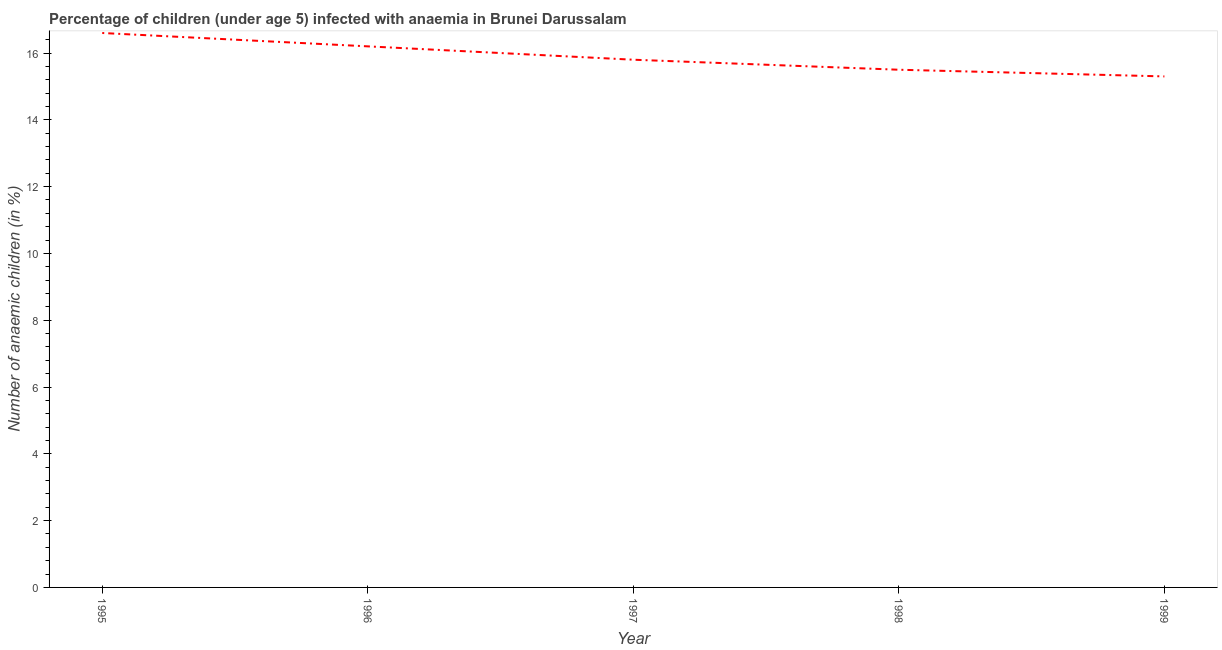What is the number of anaemic children in 1998?
Make the answer very short. 15.5. Across all years, what is the maximum number of anaemic children?
Provide a succinct answer. 16.6. Across all years, what is the minimum number of anaemic children?
Your response must be concise. 15.3. In which year was the number of anaemic children maximum?
Your response must be concise. 1995. What is the sum of the number of anaemic children?
Provide a succinct answer. 79.4. What is the difference between the number of anaemic children in 1996 and 1998?
Provide a succinct answer. 0.7. What is the average number of anaemic children per year?
Offer a very short reply. 15.88. In how many years, is the number of anaemic children greater than 11.6 %?
Your answer should be compact. 5. Do a majority of the years between 1995 and 1996 (inclusive) have number of anaemic children greater than 7.2 %?
Provide a short and direct response. Yes. What is the ratio of the number of anaemic children in 1997 to that in 1998?
Keep it short and to the point. 1.02. What is the difference between the highest and the second highest number of anaemic children?
Make the answer very short. 0.4. What is the difference between the highest and the lowest number of anaemic children?
Give a very brief answer. 1.3. In how many years, is the number of anaemic children greater than the average number of anaemic children taken over all years?
Keep it short and to the point. 2. Does the number of anaemic children monotonically increase over the years?
Your answer should be very brief. No. Are the values on the major ticks of Y-axis written in scientific E-notation?
Your answer should be compact. No. Does the graph contain any zero values?
Keep it short and to the point. No. What is the title of the graph?
Give a very brief answer. Percentage of children (under age 5) infected with anaemia in Brunei Darussalam. What is the label or title of the Y-axis?
Give a very brief answer. Number of anaemic children (in %). What is the Number of anaemic children (in %) of 1998?
Offer a terse response. 15.5. What is the difference between the Number of anaemic children (in %) in 1995 and 1996?
Provide a succinct answer. 0.4. What is the difference between the Number of anaemic children (in %) in 1995 and 1998?
Your response must be concise. 1.1. What is the difference between the Number of anaemic children (in %) in 1995 and 1999?
Provide a short and direct response. 1.3. What is the difference between the Number of anaemic children (in %) in 1996 and 1999?
Ensure brevity in your answer.  0.9. What is the difference between the Number of anaemic children (in %) in 1997 and 1999?
Offer a very short reply. 0.5. What is the difference between the Number of anaemic children (in %) in 1998 and 1999?
Your response must be concise. 0.2. What is the ratio of the Number of anaemic children (in %) in 1995 to that in 1996?
Offer a very short reply. 1.02. What is the ratio of the Number of anaemic children (in %) in 1995 to that in 1997?
Make the answer very short. 1.05. What is the ratio of the Number of anaemic children (in %) in 1995 to that in 1998?
Provide a succinct answer. 1.07. What is the ratio of the Number of anaemic children (in %) in 1995 to that in 1999?
Ensure brevity in your answer.  1.08. What is the ratio of the Number of anaemic children (in %) in 1996 to that in 1997?
Give a very brief answer. 1.02. What is the ratio of the Number of anaemic children (in %) in 1996 to that in 1998?
Give a very brief answer. 1.04. What is the ratio of the Number of anaemic children (in %) in 1996 to that in 1999?
Offer a terse response. 1.06. What is the ratio of the Number of anaemic children (in %) in 1997 to that in 1998?
Provide a succinct answer. 1.02. What is the ratio of the Number of anaemic children (in %) in 1997 to that in 1999?
Keep it short and to the point. 1.03. 